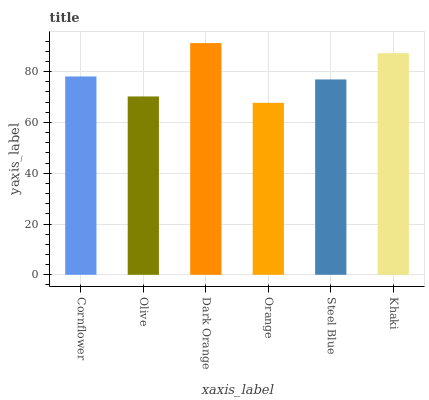Is Orange the minimum?
Answer yes or no. Yes. Is Dark Orange the maximum?
Answer yes or no. Yes. Is Olive the minimum?
Answer yes or no. No. Is Olive the maximum?
Answer yes or no. No. Is Cornflower greater than Olive?
Answer yes or no. Yes. Is Olive less than Cornflower?
Answer yes or no. Yes. Is Olive greater than Cornflower?
Answer yes or no. No. Is Cornflower less than Olive?
Answer yes or no. No. Is Cornflower the high median?
Answer yes or no. Yes. Is Steel Blue the low median?
Answer yes or no. Yes. Is Khaki the high median?
Answer yes or no. No. Is Cornflower the low median?
Answer yes or no. No. 